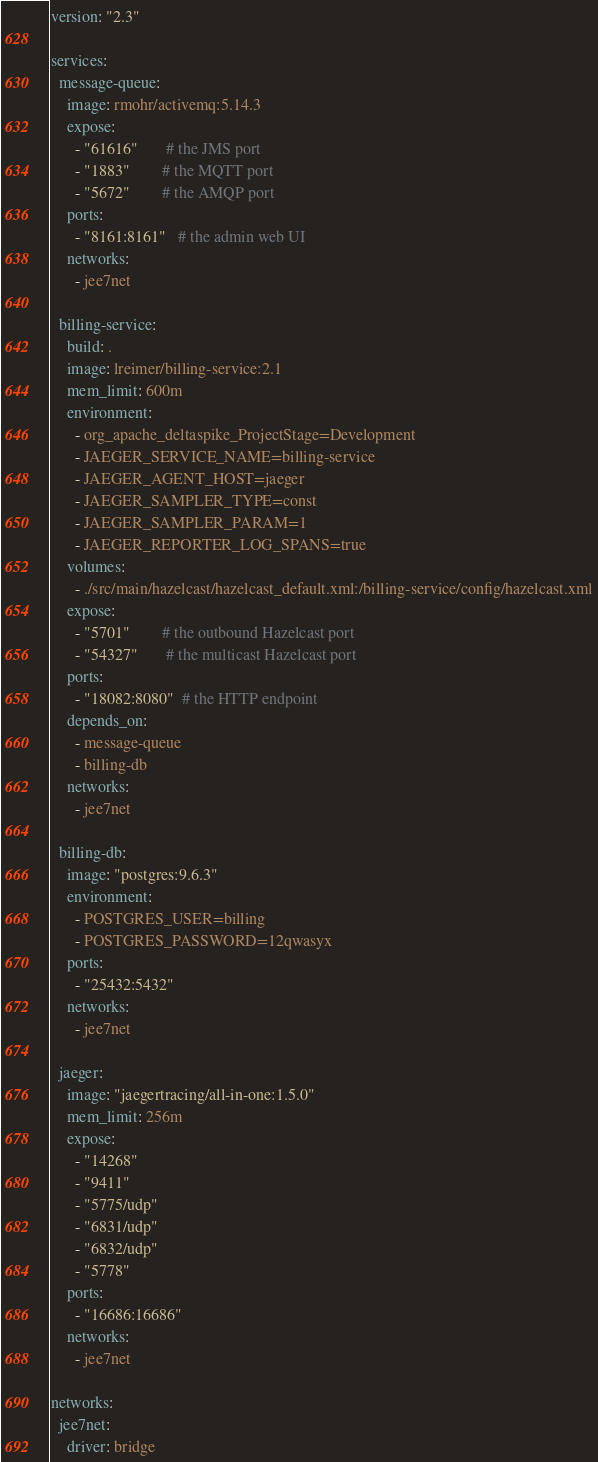<code> <loc_0><loc_0><loc_500><loc_500><_YAML_>version: "2.3"

services:
  message-queue:
    image: rmohr/activemq:5.14.3
    expose:
      - "61616"       # the JMS port
      - "1883"        # the MQTT port
      - "5672"        # the AMQP port
    ports:
      - "8161:8161"   # the admin web UI
    networks:
      - jee7net

  billing-service:
    build: .
    image: lreimer/billing-service:2.1
    mem_limit: 600m
    environment:
      - org_apache_deltaspike_ProjectStage=Development
      - JAEGER_SERVICE_NAME=billing-service
      - JAEGER_AGENT_HOST=jaeger
      - JAEGER_SAMPLER_TYPE=const
      - JAEGER_SAMPLER_PARAM=1
      - JAEGER_REPORTER_LOG_SPANS=true
    volumes:
      - ./src/main/hazelcast/hazelcast_default.xml:/billing-service/config/hazelcast.xml
    expose:
      - "5701"        # the outbound Hazelcast port
      - "54327"       # the multicast Hazelcast port
    ports:
      - "18082:8080"  # the HTTP endpoint
    depends_on:
      - message-queue
      - billing-db
    networks:
      - jee7net

  billing-db:
    image: "postgres:9.6.3"
    environment:
      - POSTGRES_USER=billing
      - POSTGRES_PASSWORD=12qwasyx
    ports:
      - "25432:5432"
    networks:
      - jee7net

  jaeger:
    image: "jaegertracing/all-in-one:1.5.0"
    mem_limit: 256m
    expose:
      - "14268"
      - "9411"
      - "5775/udp"
      - "6831/udp"
      - "6832/udp"
      - "5778"
    ports:
      - "16686:16686"
    networks:
      - jee7net

networks:
  jee7net:
    driver: bridge
</code> 